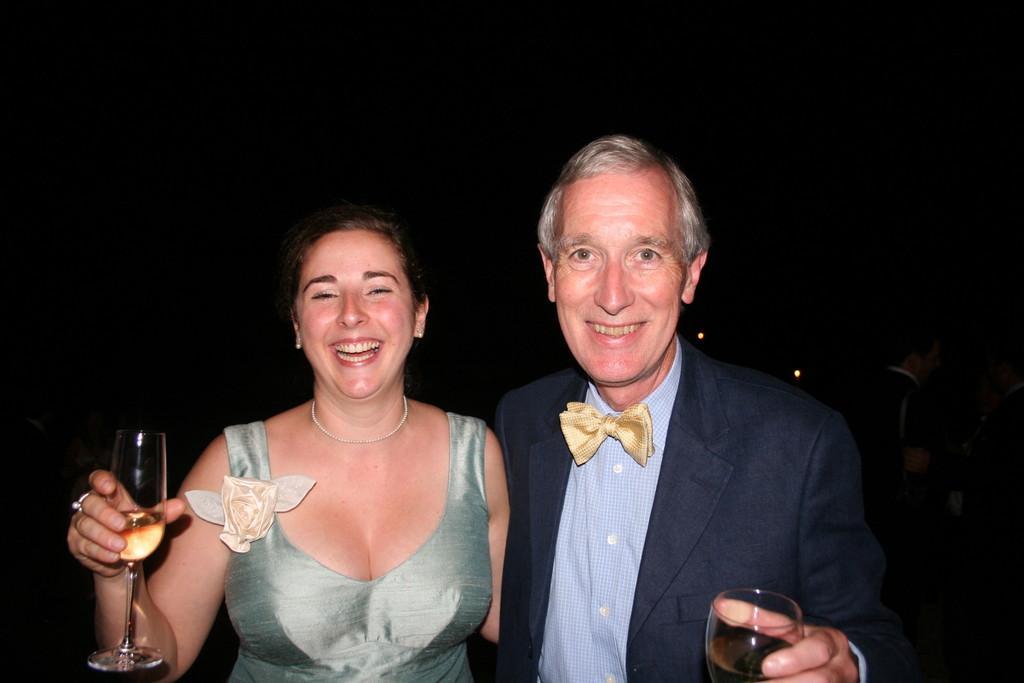Please provide a concise description of this image. In this picture we can see a man and a woman, they both are holding glasses in their hands, and they are laughing. 